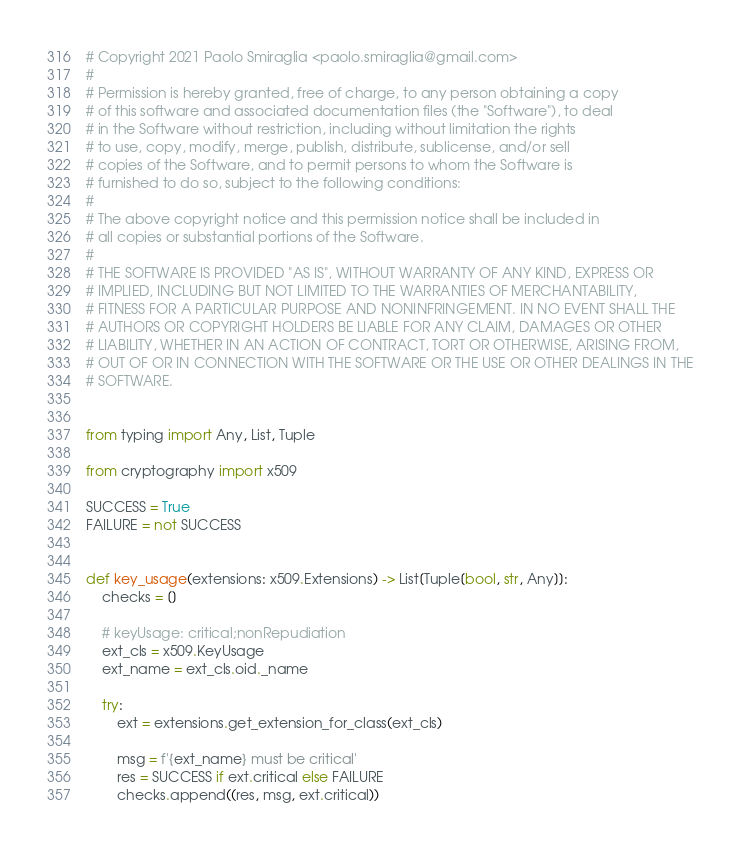Convert code to text. <code><loc_0><loc_0><loc_500><loc_500><_Python_># Copyright 2021 Paolo Smiraglia <paolo.smiraglia@gmail.com>
#
# Permission is hereby granted, free of charge, to any person obtaining a copy
# of this software and associated documentation files (the "Software"), to deal
# in the Software without restriction, including without limitation the rights
# to use, copy, modify, merge, publish, distribute, sublicense, and/or sell
# copies of the Software, and to permit persons to whom the Software is
# furnished to do so, subject to the following conditions:
#
# The above copyright notice and this permission notice shall be included in
# all copies or substantial portions of the Software.
#
# THE SOFTWARE IS PROVIDED "AS IS", WITHOUT WARRANTY OF ANY KIND, EXPRESS OR
# IMPLIED, INCLUDING BUT NOT LIMITED TO THE WARRANTIES OF MERCHANTABILITY,
# FITNESS FOR A PARTICULAR PURPOSE AND NONINFRINGEMENT. IN NO EVENT SHALL THE
# AUTHORS OR COPYRIGHT HOLDERS BE LIABLE FOR ANY CLAIM, DAMAGES OR OTHER
# LIABILITY, WHETHER IN AN ACTION OF CONTRACT, TORT OR OTHERWISE, ARISING FROM,
# OUT OF OR IN CONNECTION WITH THE SOFTWARE OR THE USE OR OTHER DEALINGS IN THE
# SOFTWARE.


from typing import Any, List, Tuple

from cryptography import x509

SUCCESS = True
FAILURE = not SUCCESS


def key_usage(extensions: x509.Extensions) -> List[Tuple[bool, str, Any]]:
    checks = []

    # keyUsage: critical;nonRepudiation
    ext_cls = x509.KeyUsage
    ext_name = ext_cls.oid._name

    try:
        ext = extensions.get_extension_for_class(ext_cls)

        msg = f'{ext_name} must be critical'
        res = SUCCESS if ext.critical else FAILURE
        checks.append((res, msg, ext.critical))
</code> 